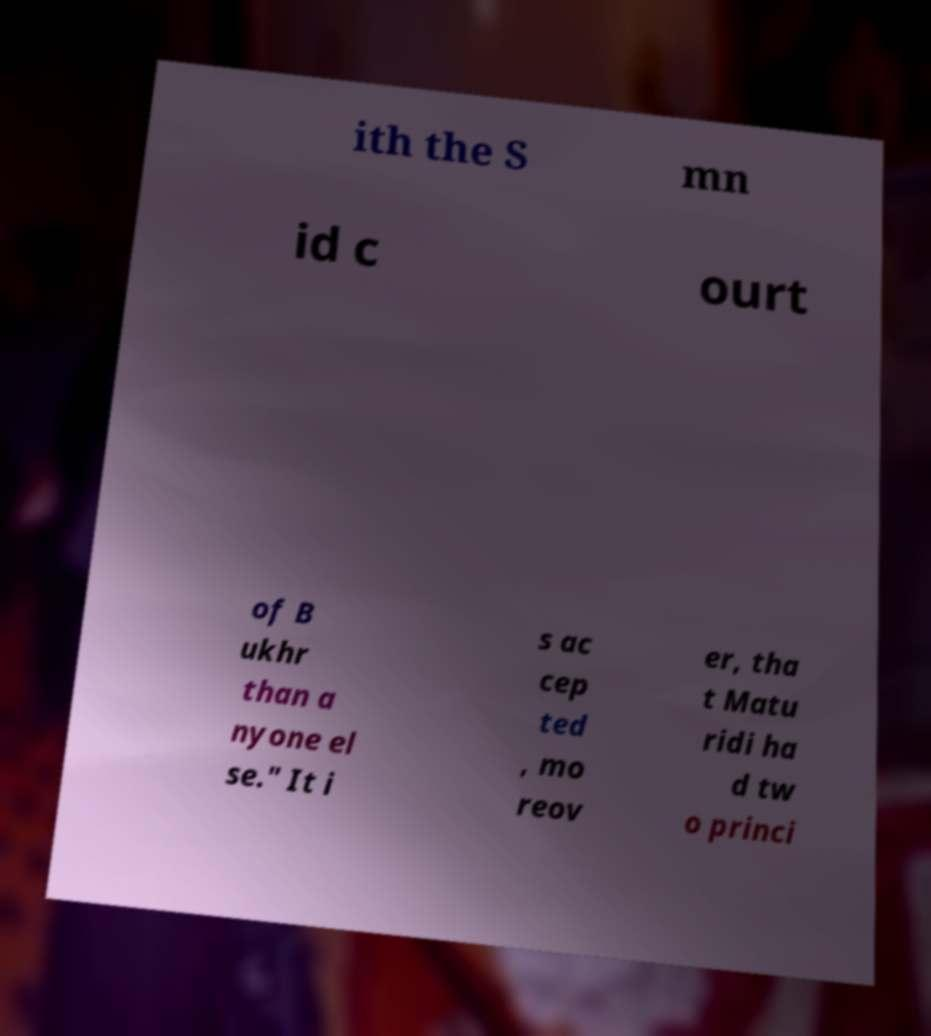Could you extract and type out the text from this image? ith the S mn id c ourt of B ukhr than a nyone el se." It i s ac cep ted , mo reov er, tha t Matu ridi ha d tw o princi 